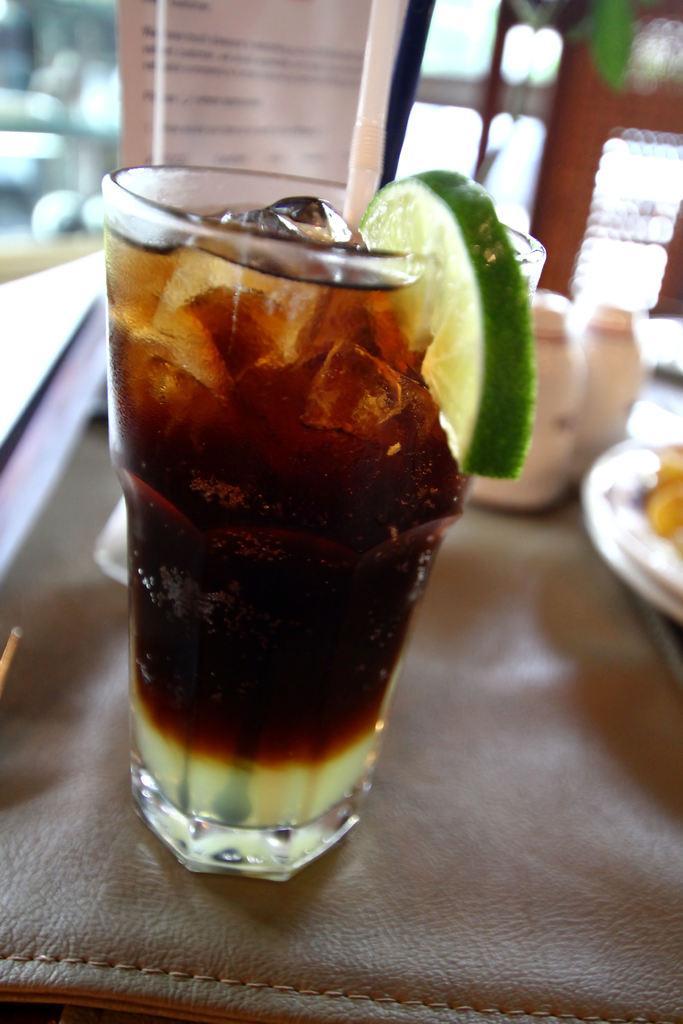Can you describe this image briefly? In this image in the foreground there is one glass, in that glass there is some drink and one lemon slice. In the background there are some bottles, plates and some objects. At the bottom there is a table. 